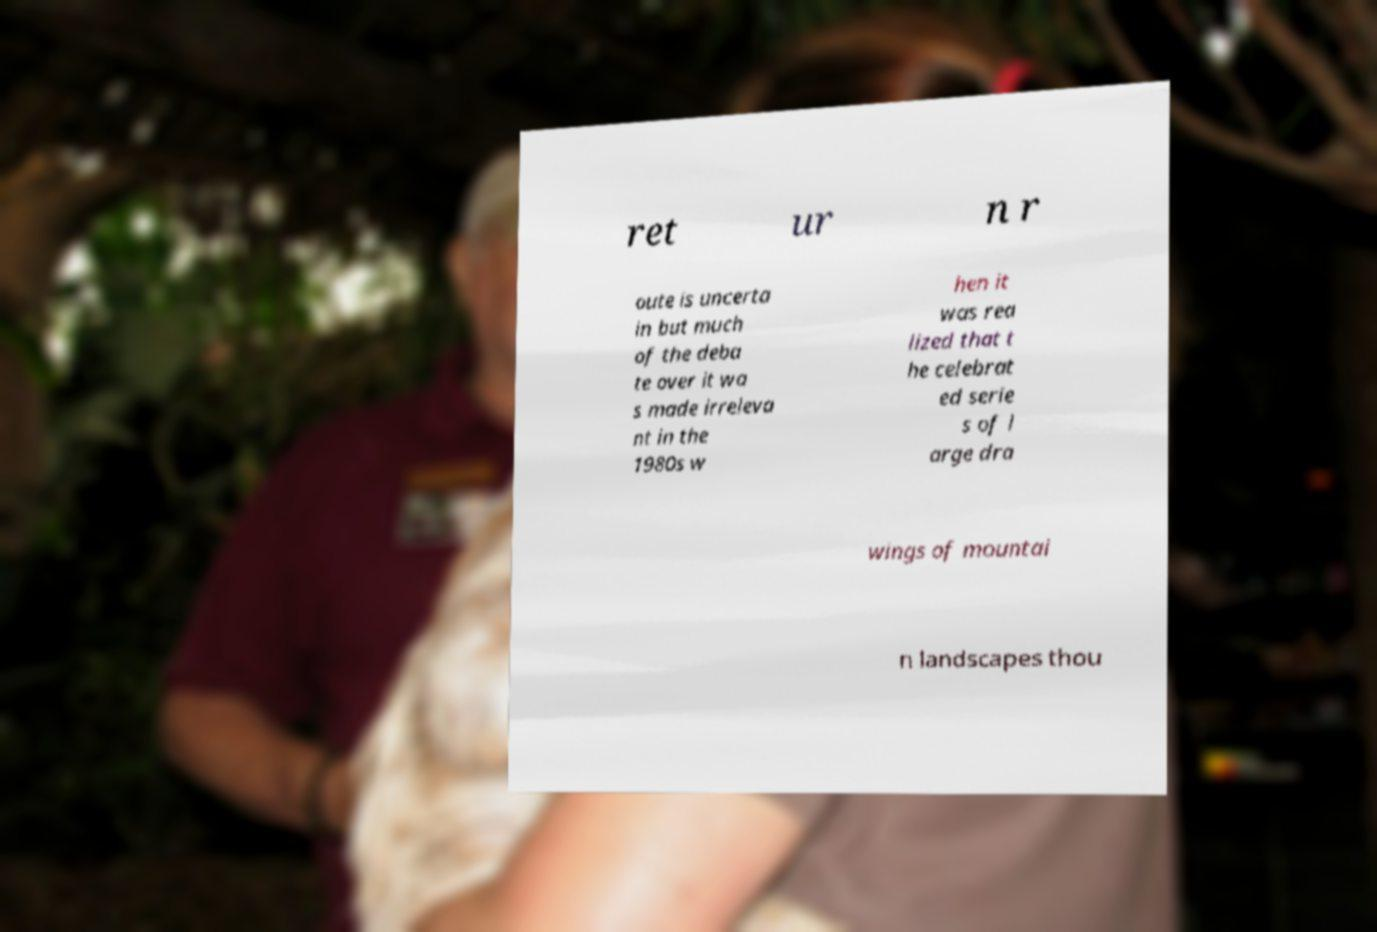Please read and relay the text visible in this image. What does it say? ret ur n r oute is uncerta in but much of the deba te over it wa s made irreleva nt in the 1980s w hen it was rea lized that t he celebrat ed serie s of l arge dra wings of mountai n landscapes thou 